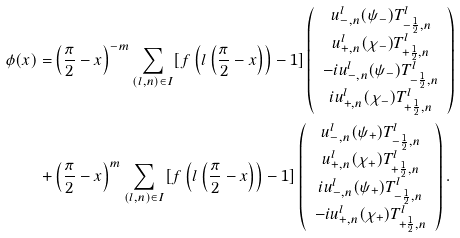Convert formula to latex. <formula><loc_0><loc_0><loc_500><loc_500>\phi ( x ) = & \left ( \frac { \pi } { 2 } - x \right ) ^ { - m } \sum _ { ( l , n ) \in I } [ f \left ( l \left ( \frac { \pi } { 2 } - x \right ) \right ) - 1 ] \left ( \begin{array} { c } u _ { - , n } ^ { l } ( \psi _ { - } ) T ^ { l } _ { - \frac { 1 } { 2 } , n } \\ u _ { + , n } ^ { l } ( \chi _ { - } ) T ^ { l } _ { + \frac { 1 } { 2 } , n } \\ - i u _ { - , n } ^ { l } ( \psi _ { - } ) T ^ { l } _ { - \frac { 1 } { 2 } , n } \\ i u _ { + , n } ^ { l } ( \chi _ { - } ) T ^ { l } _ { + \frac { 1 } { 2 } , n } \end{array} \right ) \\ + & \left ( \frac { \pi } { 2 } - x \right ) ^ { m } \sum _ { ( l , n ) \in I } [ f \left ( l \left ( \frac { \pi } { 2 } - x \right ) \right ) - 1 ] \left ( \begin{array} { c } u _ { - , n } ^ { l } ( \psi _ { + } ) T ^ { l } _ { - \frac { 1 } { 2 } , n } \\ u _ { + , n } ^ { l } ( \chi _ { + } ) T ^ { l } _ { + \frac { 1 } { 2 } , n } \\ i u _ { - , n } ^ { l } ( \psi _ { + } ) T ^ { l } _ { - \frac { 1 } { 2 } , n } \\ - i u _ { + , n } ^ { l } ( \chi _ { + } ) T ^ { l } _ { + \frac { 1 } { 2 } , n } \end{array} \right ) .</formula> 